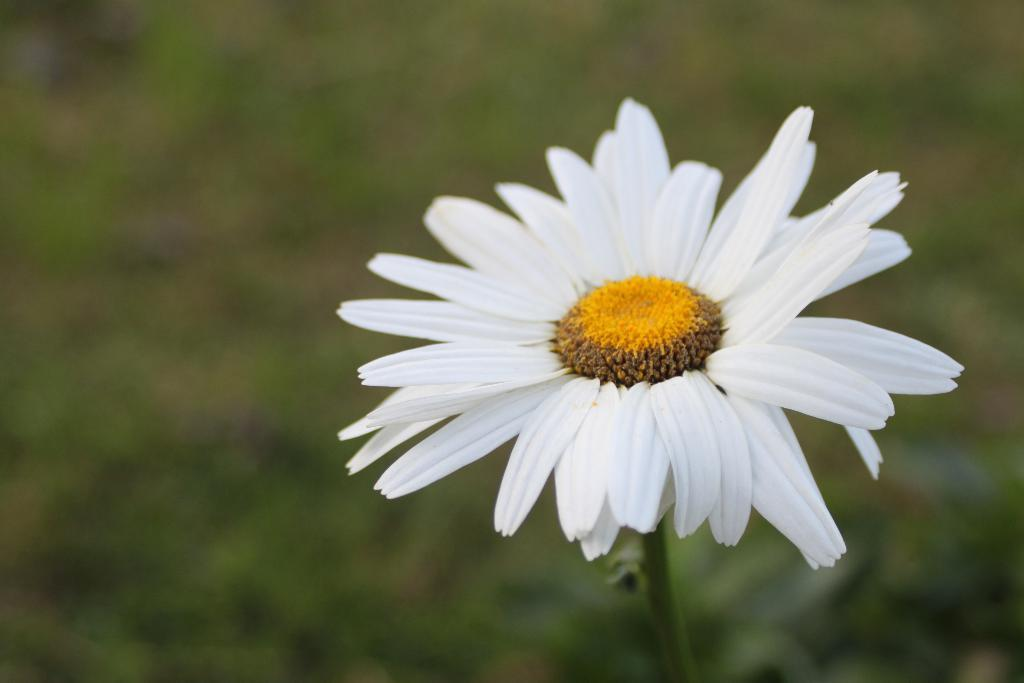What is the main subject of the image? There is a flower in the image. Can you describe the colors of the flower? The flower has white and yellow colors. How many basketballs are visible in the image? There are no basketballs present in the image. What type of sign is displayed near the flower? There is no sign present in the image. 